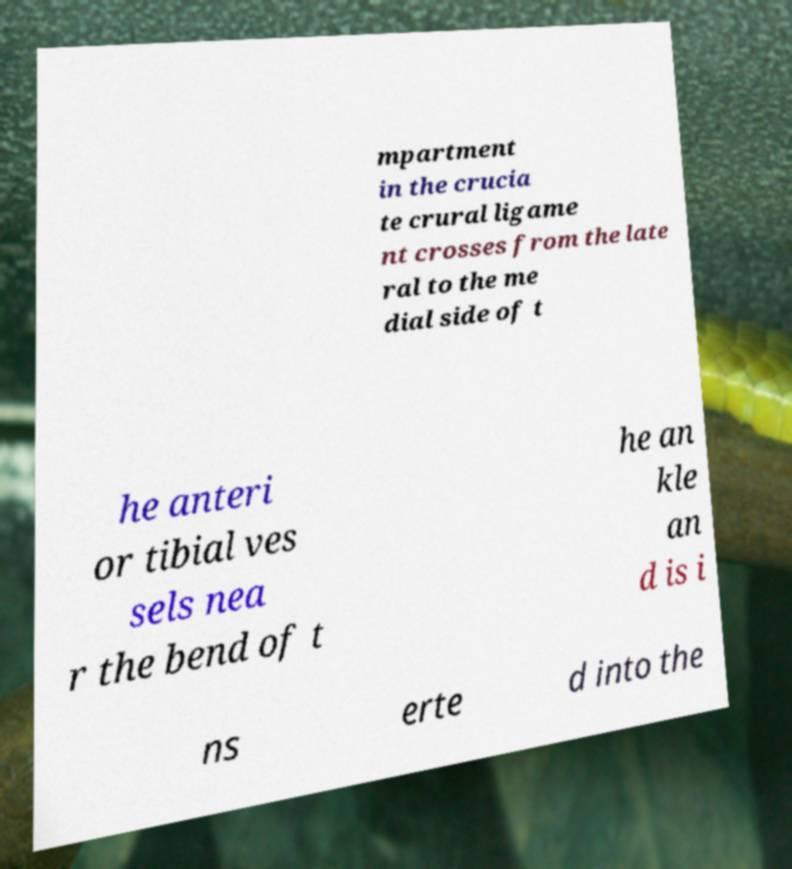I need the written content from this picture converted into text. Can you do that? mpartment in the crucia te crural ligame nt crosses from the late ral to the me dial side of t he anteri or tibial ves sels nea r the bend of t he an kle an d is i ns erte d into the 